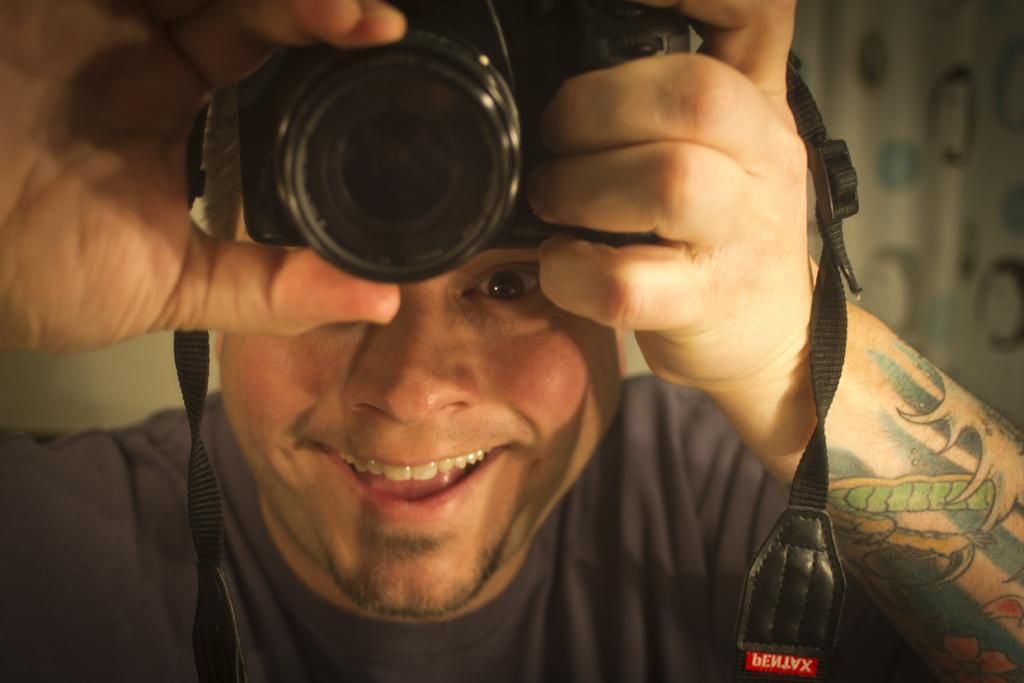What is the person in the image doing? The person in the image is smiling. What is the person holding in the image? The person is holding a camera. How is the camera positioned in relation to the person? The camera is positioned on top of the person. Can you describe any visible features on the person's hand? The person has tattoos on their right hand. What can be seen in the background of the image? There are curtains visible in the background. How many clocks are hanging on the wall behind the person in the image? There are no clocks visible in the image; only curtains can be seen in the background. Is there a swing present in the image? No, there is no swing present in the image. 